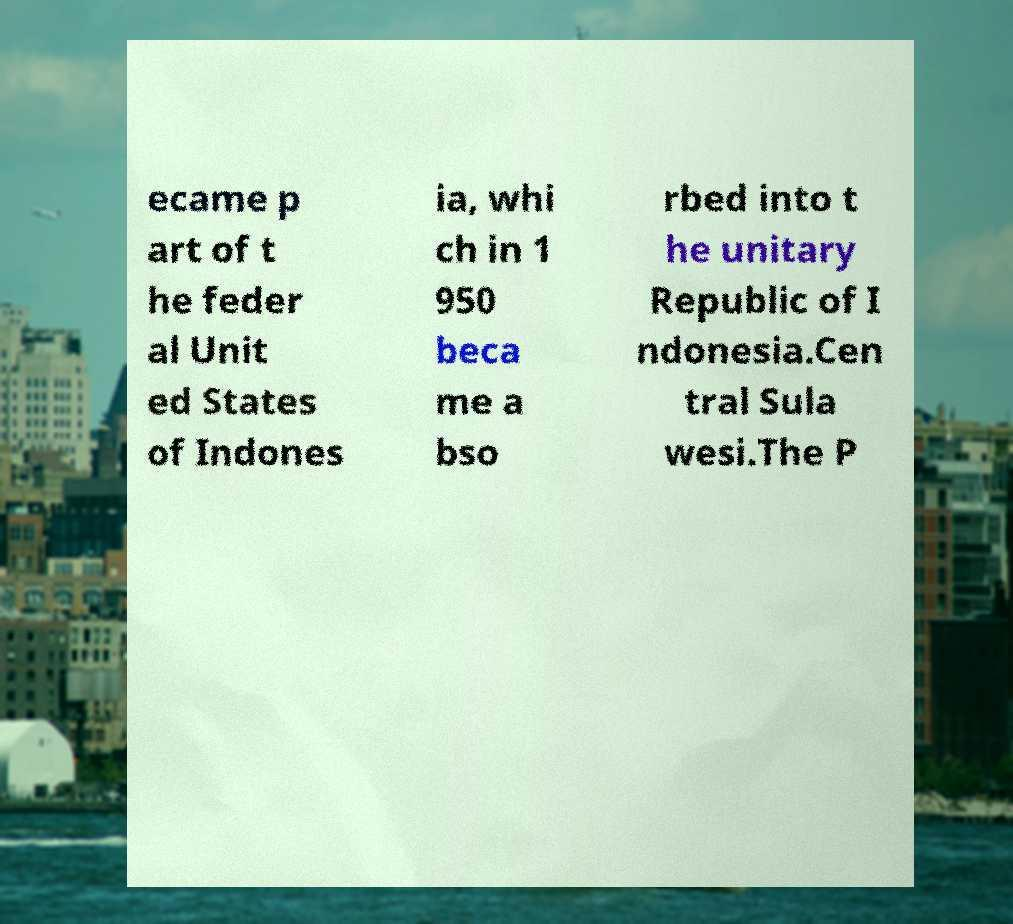Could you assist in decoding the text presented in this image and type it out clearly? ecame p art of t he feder al Unit ed States of Indones ia, whi ch in 1 950 beca me a bso rbed into t he unitary Republic of I ndonesia.Cen tral Sula wesi.The P 